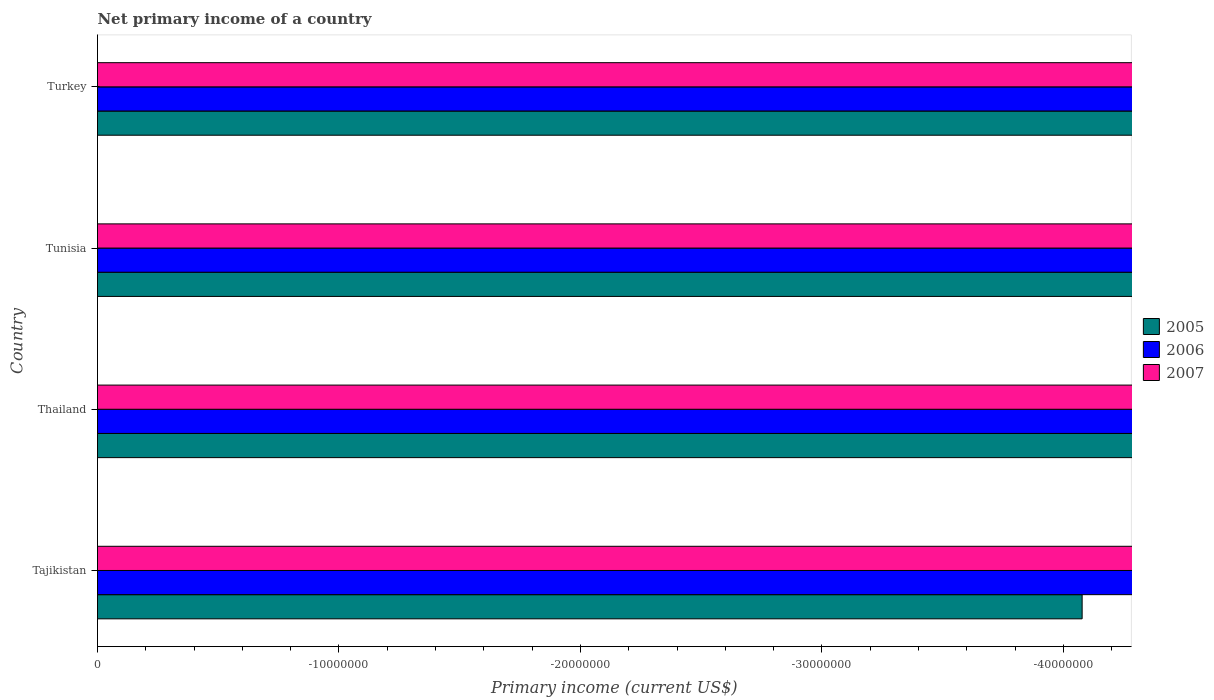Are the number of bars on each tick of the Y-axis equal?
Make the answer very short. Yes. How many bars are there on the 2nd tick from the top?
Your response must be concise. 0. How many bars are there on the 3rd tick from the bottom?
Provide a succinct answer. 0. What is the label of the 2nd group of bars from the top?
Make the answer very short. Tunisia. What is the total primary income in 2005 in the graph?
Ensure brevity in your answer.  0. What is the average primary income in 2006 per country?
Your answer should be compact. 0. Is it the case that in every country, the sum of the primary income in 2005 and primary income in 2007 is greater than the primary income in 2006?
Keep it short and to the point. No. How many bars are there?
Ensure brevity in your answer.  0. Are all the bars in the graph horizontal?
Give a very brief answer. Yes. Are the values on the major ticks of X-axis written in scientific E-notation?
Make the answer very short. No. Does the graph contain any zero values?
Your response must be concise. Yes. Does the graph contain grids?
Ensure brevity in your answer.  No. Where does the legend appear in the graph?
Ensure brevity in your answer.  Center right. How many legend labels are there?
Provide a succinct answer. 3. How are the legend labels stacked?
Give a very brief answer. Vertical. What is the title of the graph?
Provide a succinct answer. Net primary income of a country. What is the label or title of the X-axis?
Provide a short and direct response. Primary income (current US$). What is the label or title of the Y-axis?
Your answer should be very brief. Country. What is the Primary income (current US$) in 2006 in Tajikistan?
Your response must be concise. 0. What is the Primary income (current US$) of 2007 in Tajikistan?
Give a very brief answer. 0. What is the Primary income (current US$) of 2005 in Thailand?
Provide a short and direct response. 0. What is the Primary income (current US$) of 2006 in Thailand?
Your answer should be compact. 0. What is the Primary income (current US$) in 2007 in Thailand?
Give a very brief answer. 0. What is the Primary income (current US$) in 2005 in Tunisia?
Your answer should be very brief. 0. What is the Primary income (current US$) of 2006 in Tunisia?
Provide a succinct answer. 0. What is the Primary income (current US$) of 2005 in Turkey?
Your answer should be compact. 0. What is the total Primary income (current US$) of 2005 in the graph?
Offer a very short reply. 0. What is the average Primary income (current US$) in 2005 per country?
Give a very brief answer. 0. 